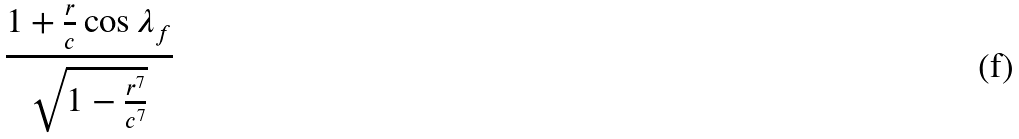Convert formula to latex. <formula><loc_0><loc_0><loc_500><loc_500>\frac { 1 + \frac { r } { c } \cos \lambda _ { f } } { \sqrt { 1 - \frac { r ^ { 7 } } { c ^ { 7 } } } }</formula> 